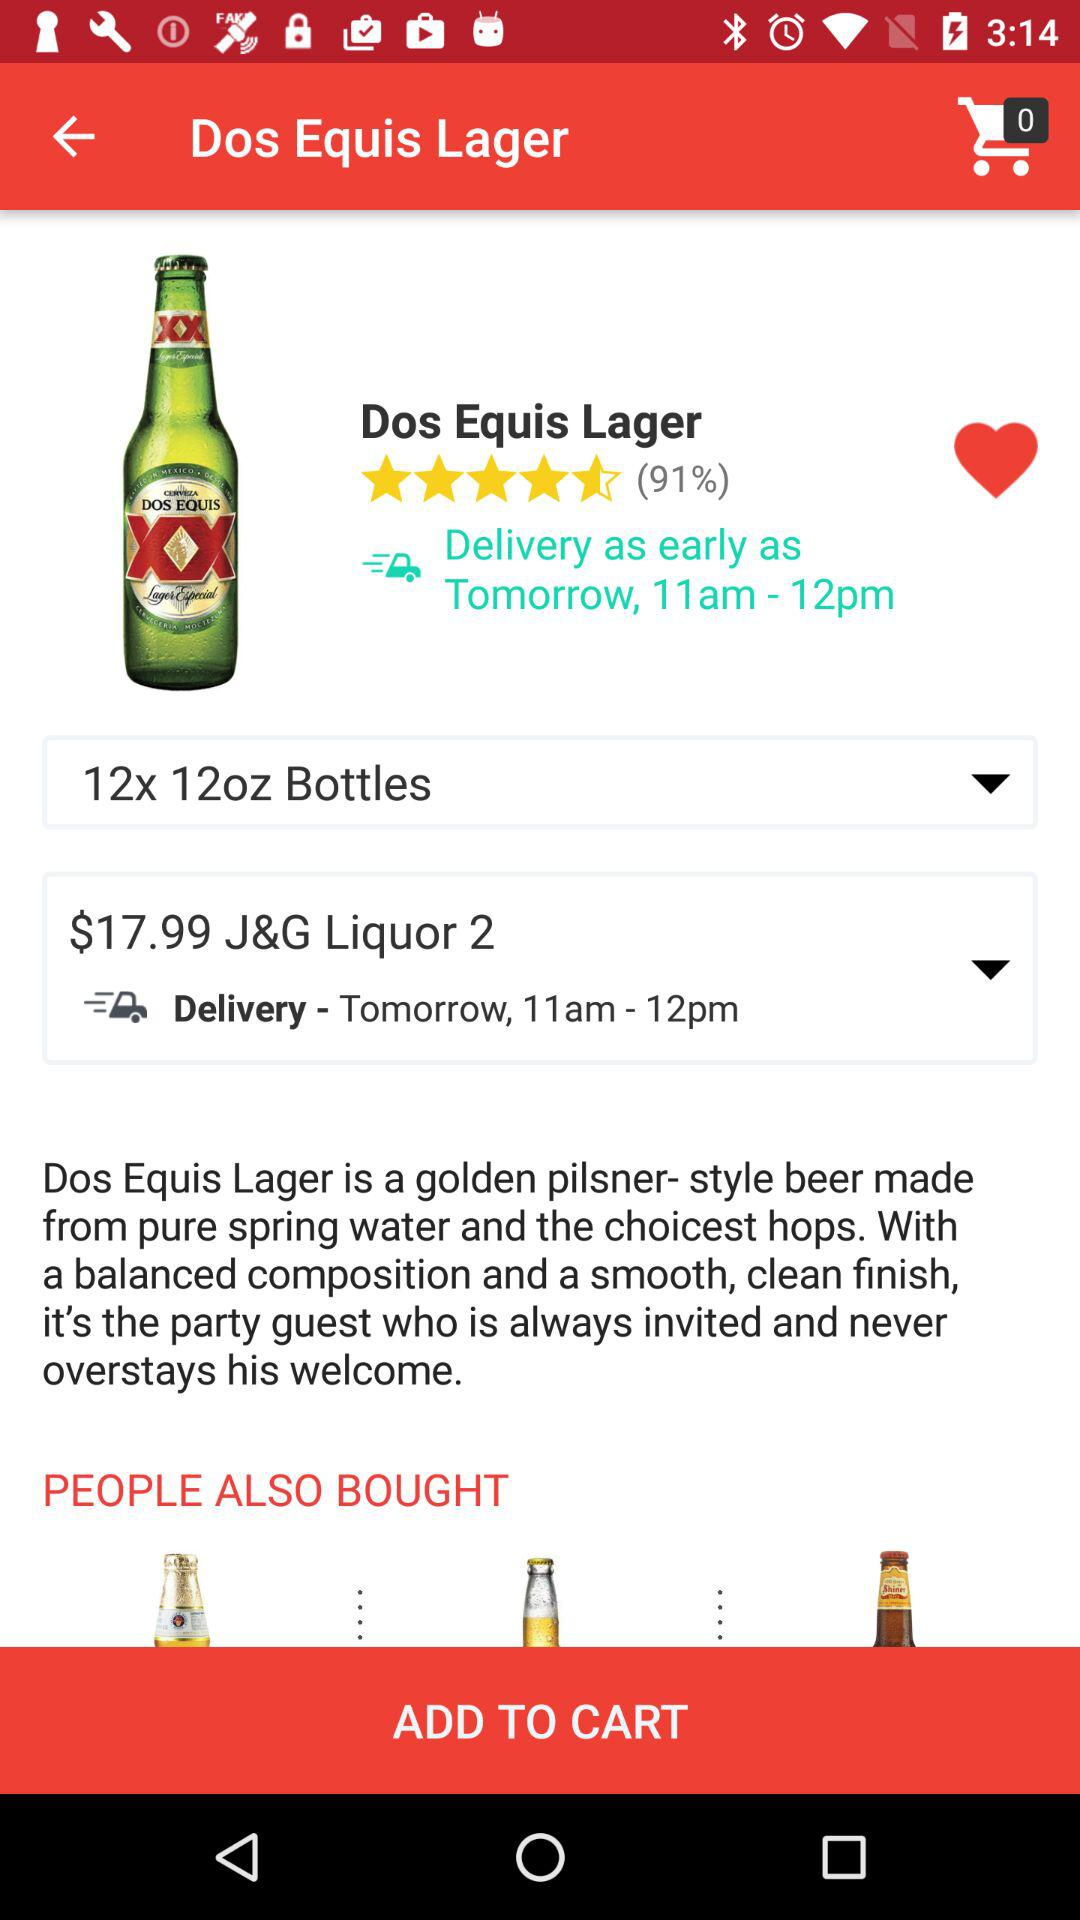What is the quantity? The quantity is 12x 12oz bottles. 